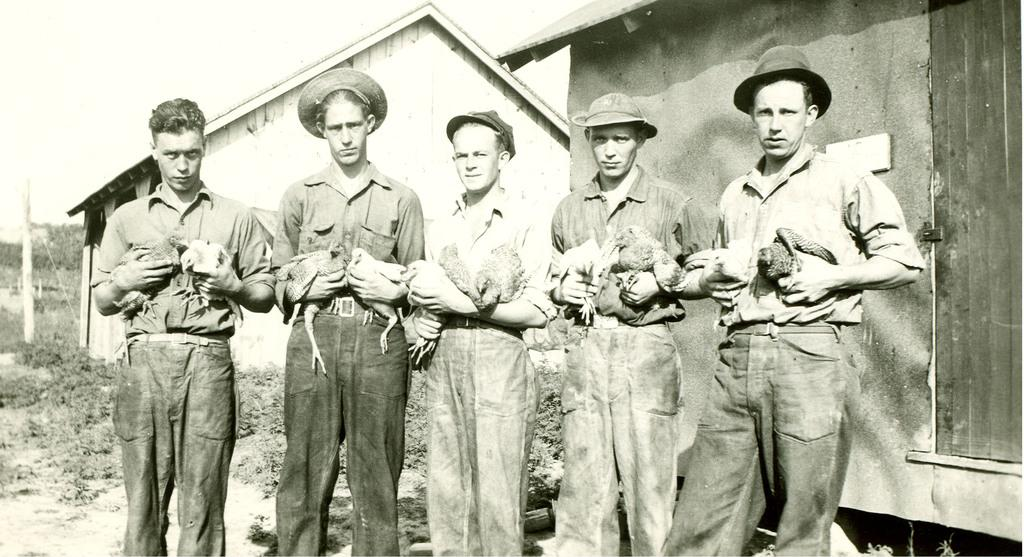How many people are in the image? There is a group of people in the image. What are the people doing in the image? The people are standing and holding birds. What can be seen in the background of the image? There is a house and trees in the background of the image. What is the color scheme of the image? The image is black and white. Is there a bike visible in the image? No, there is no bike present in the image. Who is the representative of the group in the image? The image does not indicate a specific representative for the group. 